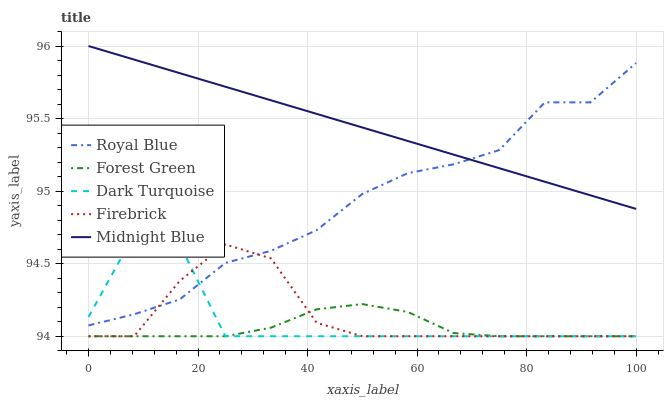Does Forest Green have the minimum area under the curve?
Answer yes or no. Yes. Does Midnight Blue have the maximum area under the curve?
Answer yes or no. Yes. Does Midnight Blue have the minimum area under the curve?
Answer yes or no. No. Does Forest Green have the maximum area under the curve?
Answer yes or no. No. Is Midnight Blue the smoothest?
Answer yes or no. Yes. Is Dark Turquoise the roughest?
Answer yes or no. Yes. Is Forest Green the smoothest?
Answer yes or no. No. Is Forest Green the roughest?
Answer yes or no. No. Does Midnight Blue have the lowest value?
Answer yes or no. No. Does Forest Green have the highest value?
Answer yes or no. No. Is Dark Turquoise less than Midnight Blue?
Answer yes or no. Yes. Is Royal Blue greater than Forest Green?
Answer yes or no. Yes. Does Dark Turquoise intersect Midnight Blue?
Answer yes or no. No. 